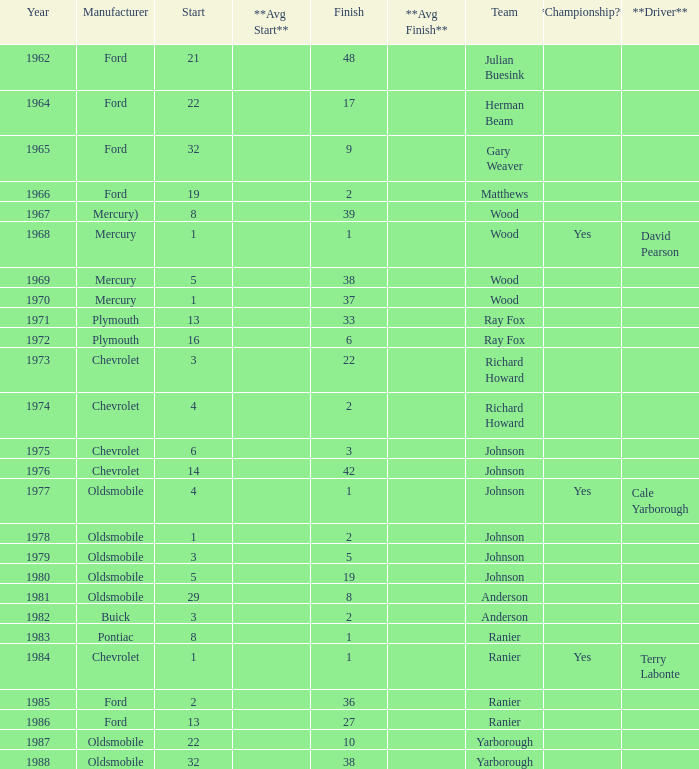What is the smallest finish time for a race where start was less than 3, buick was the manufacturer, and the race was held after 1978? None. 